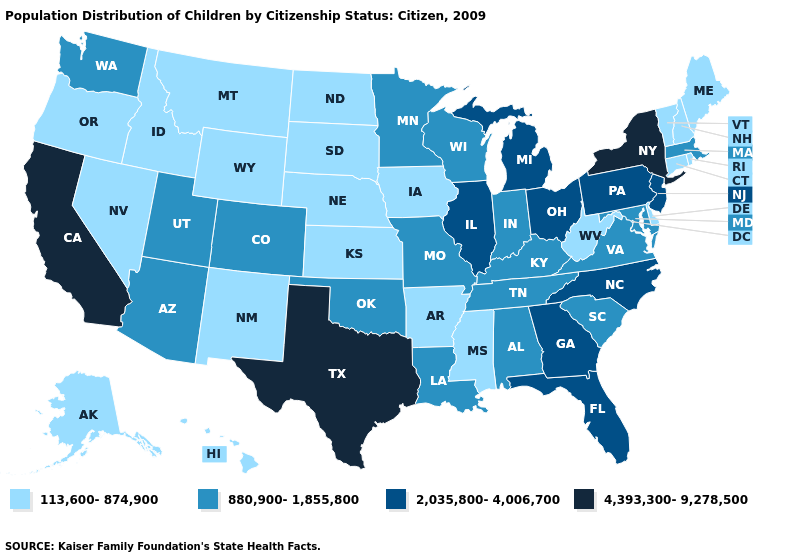Does South Carolina have a higher value than West Virginia?
Be succinct. Yes. What is the value of Maine?
Write a very short answer. 113,600-874,900. Does Rhode Island have a lower value than Maine?
Quick response, please. No. Does Idaho have the highest value in the West?
Short answer required. No. Does Massachusetts have the highest value in the Northeast?
Be succinct. No. Among the states that border California , does Arizona have the lowest value?
Give a very brief answer. No. What is the value of Connecticut?
Short answer required. 113,600-874,900. What is the value of New Jersey?
Give a very brief answer. 2,035,800-4,006,700. Name the states that have a value in the range 113,600-874,900?
Short answer required. Alaska, Arkansas, Connecticut, Delaware, Hawaii, Idaho, Iowa, Kansas, Maine, Mississippi, Montana, Nebraska, Nevada, New Hampshire, New Mexico, North Dakota, Oregon, Rhode Island, South Dakota, Vermont, West Virginia, Wyoming. What is the value of Ohio?
Give a very brief answer. 2,035,800-4,006,700. Among the states that border Vermont , does New York have the lowest value?
Quick response, please. No. Does Nebraska have the same value as Wyoming?
Concise answer only. Yes. Does the first symbol in the legend represent the smallest category?
Concise answer only. Yes. Among the states that border Florida , does Alabama have the highest value?
Keep it brief. No. What is the value of North Dakota?
Quick response, please. 113,600-874,900. 